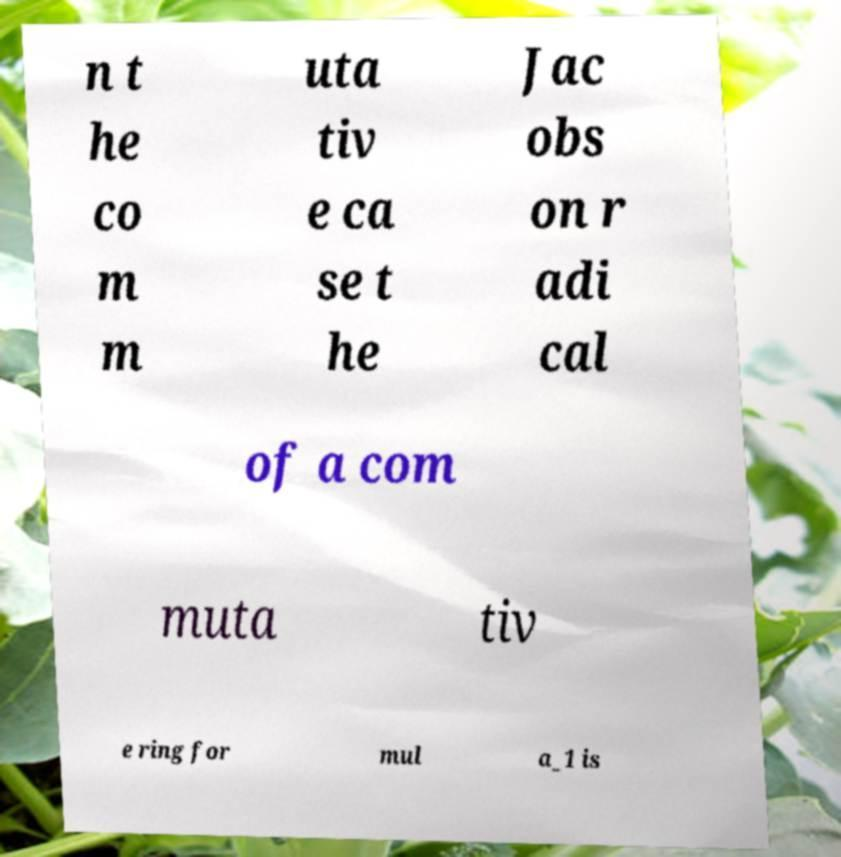I need the written content from this picture converted into text. Can you do that? n t he co m m uta tiv e ca se t he Jac obs on r adi cal of a com muta tiv e ring for mul a_1 is 